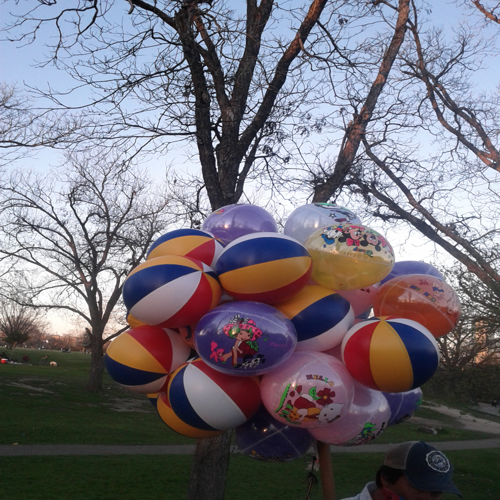Is the image of good quality? The image could be considered of moderate quality. It appears to be clear and shows a vibrant array of colorful balloons in what looks like a park setting. Details of the balloons can be discerned clearly, suggesting a decent resolution. However, it's important to note that 'good quality' can depend on the intended use of the image. For casual viewing, this image seems satisfactory, but for professional or printing purposes, a higher resolution might be desired. 